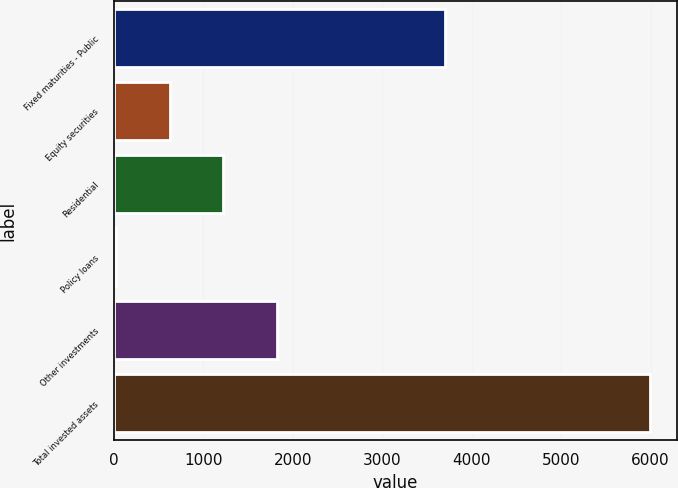Convert chart to OTSL. <chart><loc_0><loc_0><loc_500><loc_500><bar_chart><fcel>Fixed maturities - Public<fcel>Equity securities<fcel>Residential<fcel>Policy loans<fcel>Other investments<fcel>Total invested assets<nl><fcel>3698.7<fcel>623.76<fcel>1220.82<fcel>26.7<fcel>1817.88<fcel>5997.3<nl></chart> 